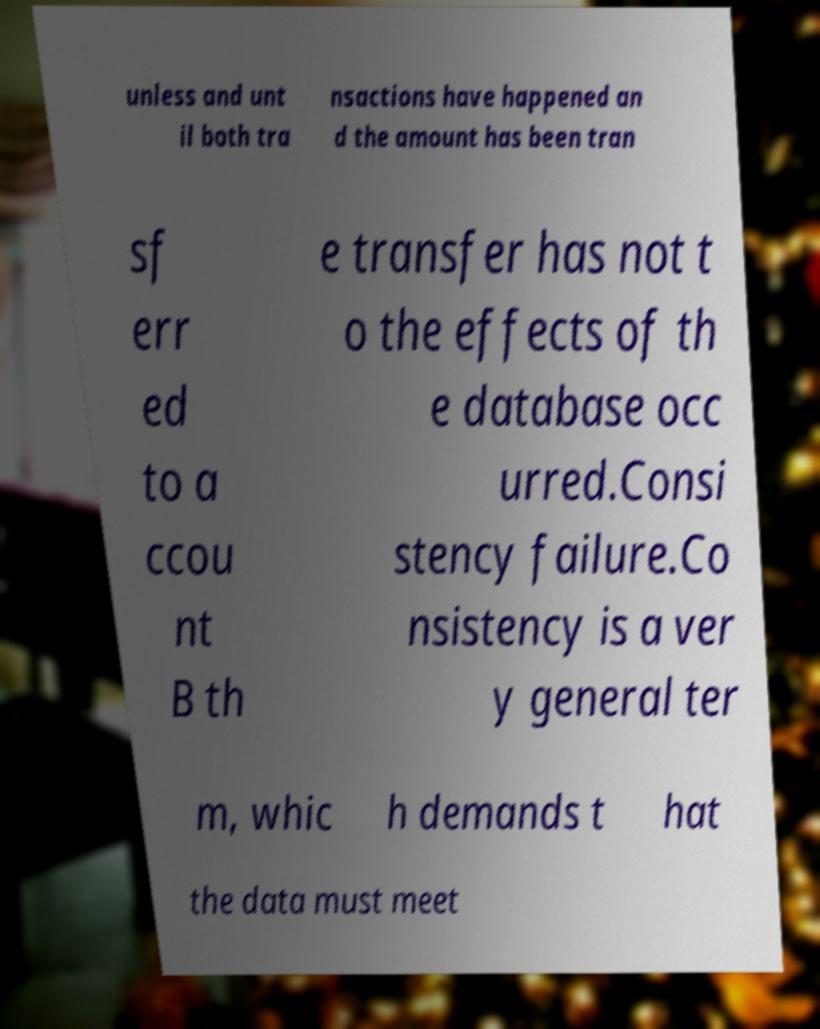For documentation purposes, I need the text within this image transcribed. Could you provide that? unless and unt il both tra nsactions have happened an d the amount has been tran sf err ed to a ccou nt B th e transfer has not t o the effects of th e database occ urred.Consi stency failure.Co nsistency is a ver y general ter m, whic h demands t hat the data must meet 